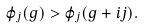Convert formula to latex. <formula><loc_0><loc_0><loc_500><loc_500>\varphi _ { j } ( g ) > \varphi _ { j } ( g + i j ) .</formula> 